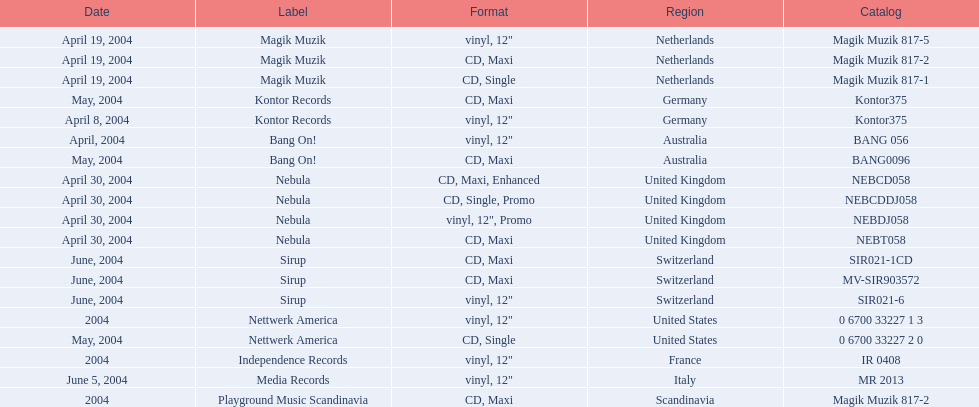What label was used by the netherlands in love comes again? Magik Muzik. What label was used in germany? Kontor Records. What label was used in france? Independence Records. 